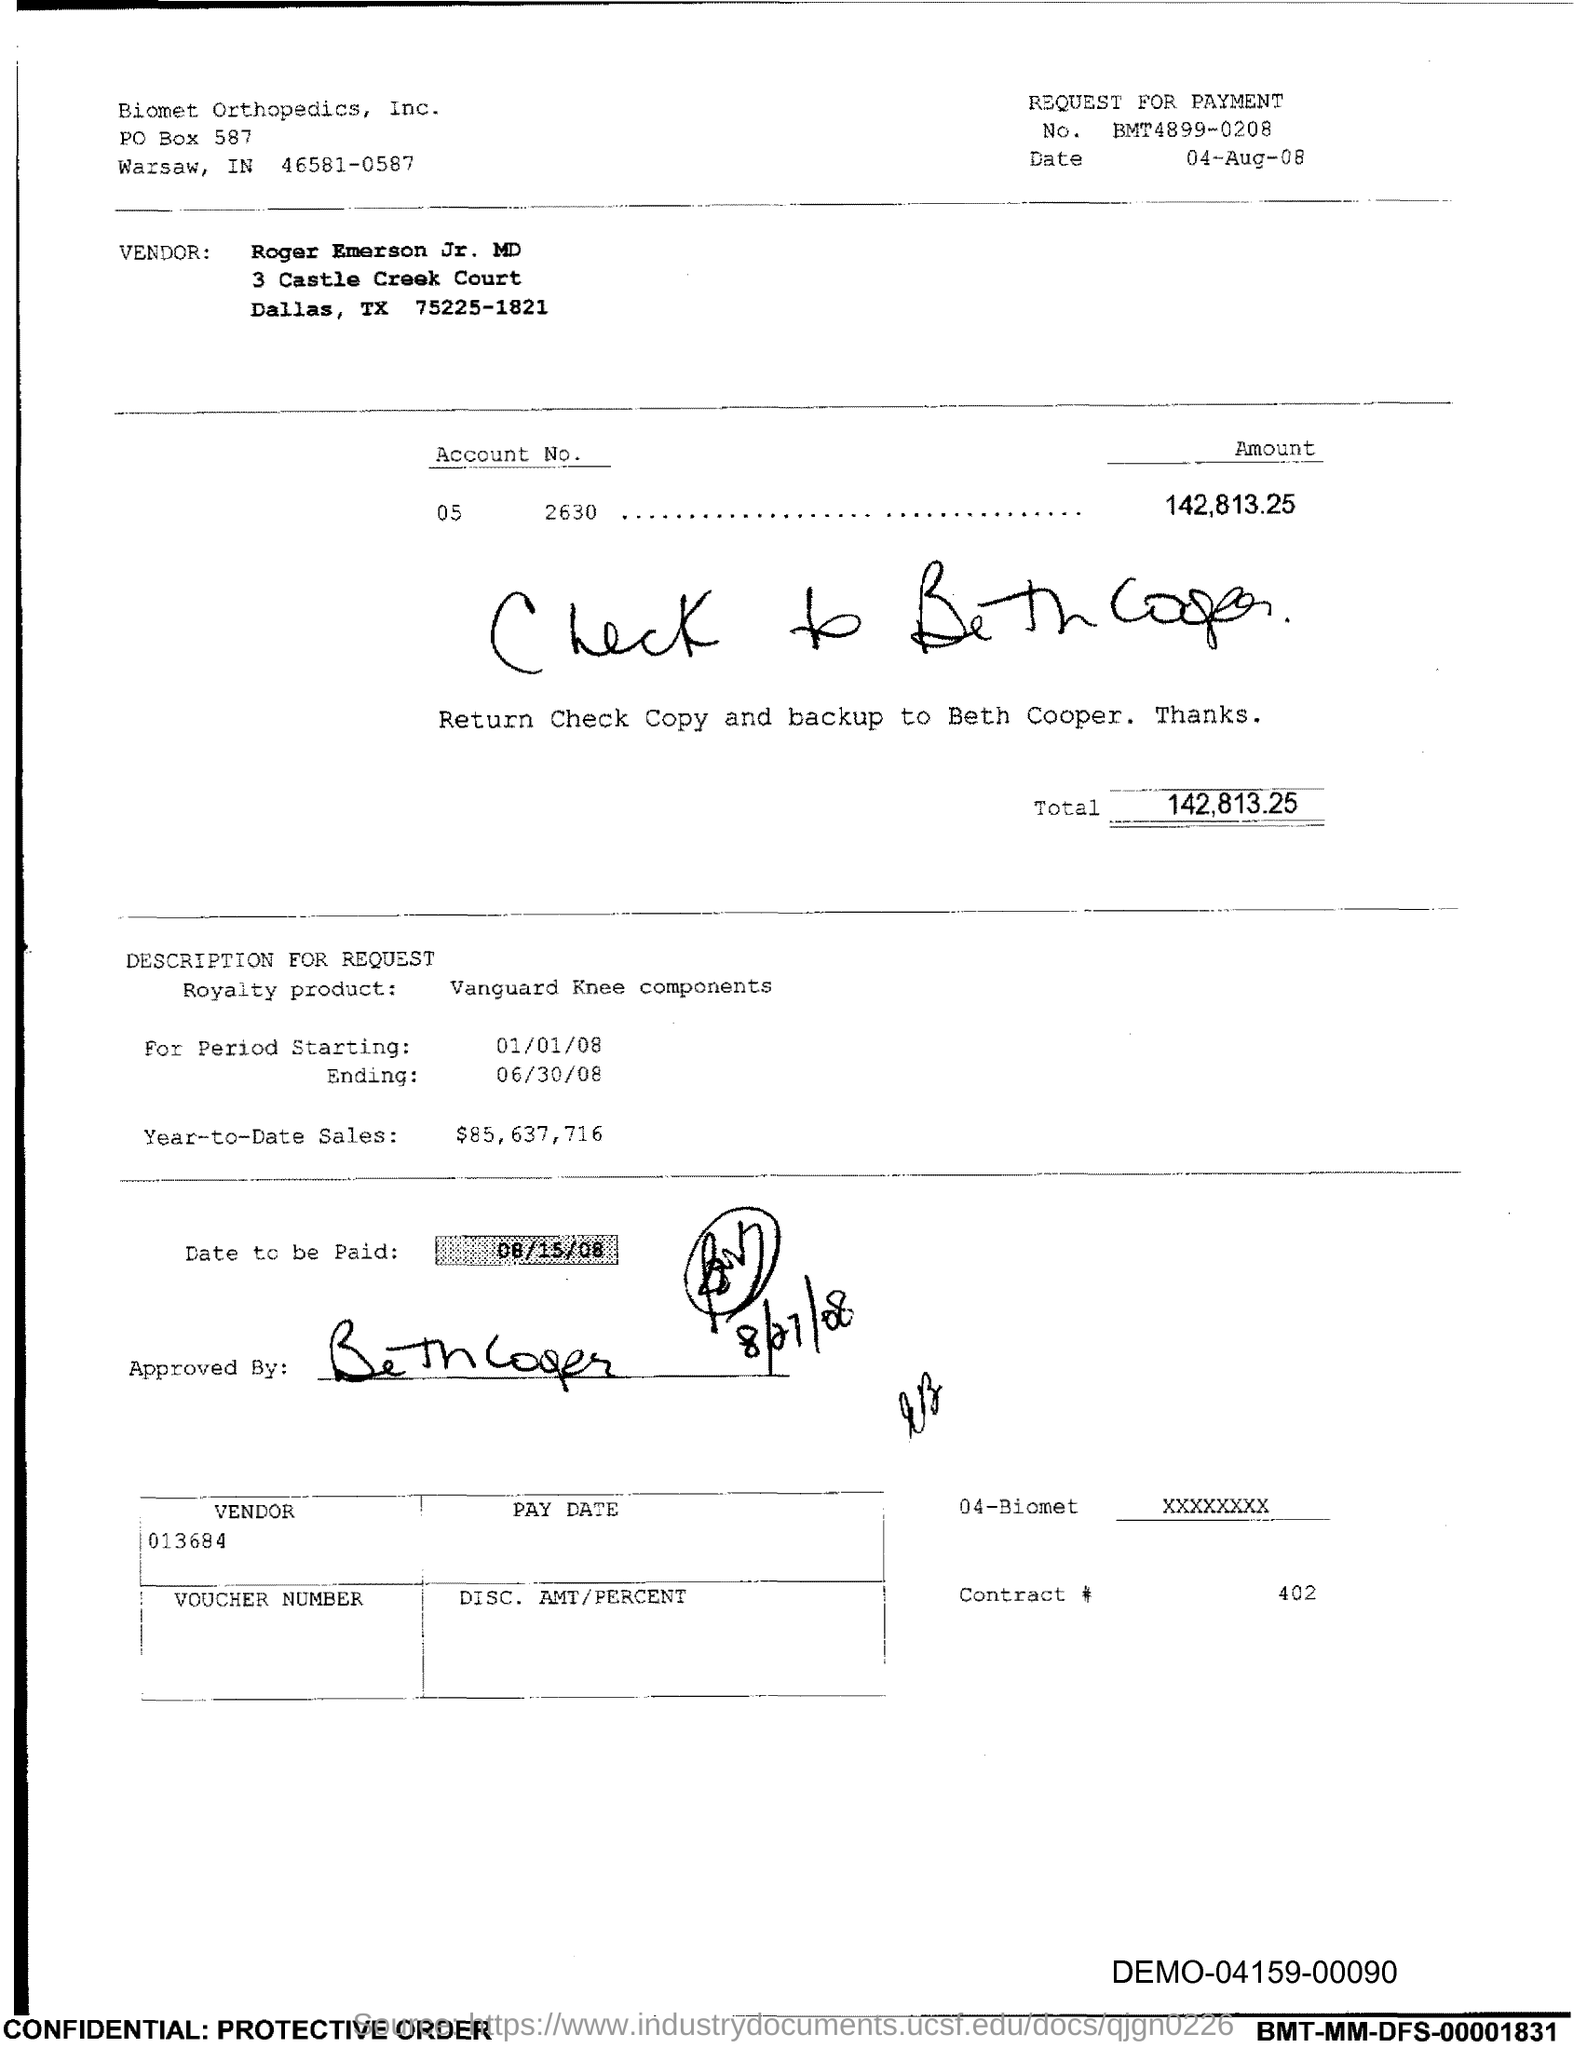List a handful of essential elements in this visual. On what date is the payment due? The date to be paid is August 15, 2008. The year-to-date sales amount is $85,637,716. The date mentioned on the top right corner is 04-aug-08. The total amount is 142,813 dollars and 25 cents. I would like to know the contract number, specifically 402... 